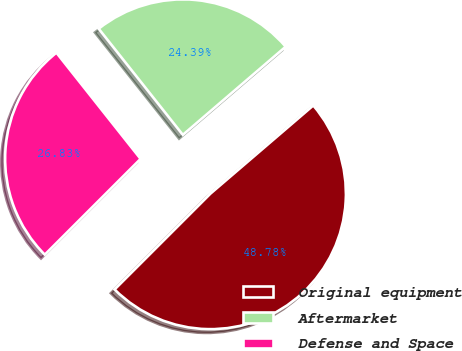Convert chart to OTSL. <chart><loc_0><loc_0><loc_500><loc_500><pie_chart><fcel>Original equipment<fcel>Aftermarket<fcel>Defense and Space<nl><fcel>48.78%<fcel>24.39%<fcel>26.83%<nl></chart> 